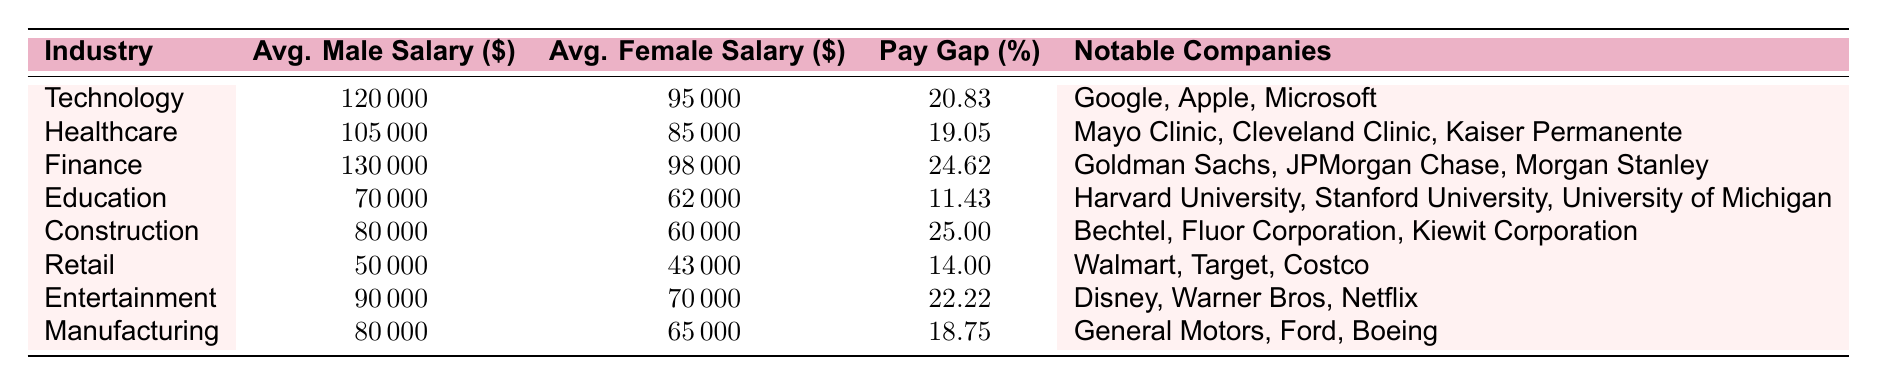What is the average male salary in the Technology industry? In the row corresponding to the Technology industry, the average male salary is found in the second column, which lists it as 120000.
Answer: 120000 Which industry has the highest average female salary? By comparing the average female salaries across all industries listed in the table, the Finance industry has the highest figure of 98000.
Answer: Finance What is the pay gap percentage in the Construction industry? The pay gap percentage for the Construction industry is found in the fourth column of its respective row, which shows it as 25.00.
Answer: 25.00 What is the difference between the average male salary in Finance and Education industries? The average male salary in Finance is 130000, and in Education, it is 70000. Calculating the difference gives 130000 - 70000 = 60000.
Answer: 60000 Is the pay gap in Retail greater than in Healthcare? The pay gap in Retail is 14.00%, while in Healthcare it is 19.05%. Since 14.00 is less than 19.05, the statement is false.
Answer: No Which industry has the lowest pay gap percentage? By examining the pay gap percentages listed in the table, the Education industry has the lowest at 11.43%.
Answer: Education What is the average of average female salaries across all industries? The average female salaries are: 95000 (Technology), 85000 (Healthcare), 98000 (Finance), 62000 (Education), 60000 (Construction), 43000 (Retail), 70000 (Entertainment), 65000 (Manufacturing). Summing these gives 95000 + 85000 + 98000 + 62000 + 60000 + 43000 + 70000 + 65000 = 525000. Dividing by the total number of industries (8) gives an average of 525000 / 8 = 65625.
Answer: 65625 Does the average male salary in Entertainment exceed 90000? The average male salary in Entertainment is listed as 90000, and since the question asks if it exceeds this figure, the answer is false.
Answer: No Which notable companies are associated with the Healthcare industry? In the Healthcare row, the notable companies are specified in the last column, which lists Mayo Clinic, Cleveland Clinic, and Kaiser Permanente.
Answer: Mayo Clinic, Cleveland Clinic, Kaiser Permanente 